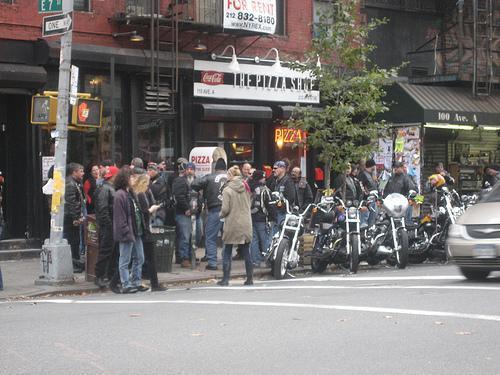How many cars are there?
Give a very brief answer. 1. How many fire escapes are pictured?
Give a very brief answer. 2. How many trees are pictured?
Give a very brief answer. 1. 